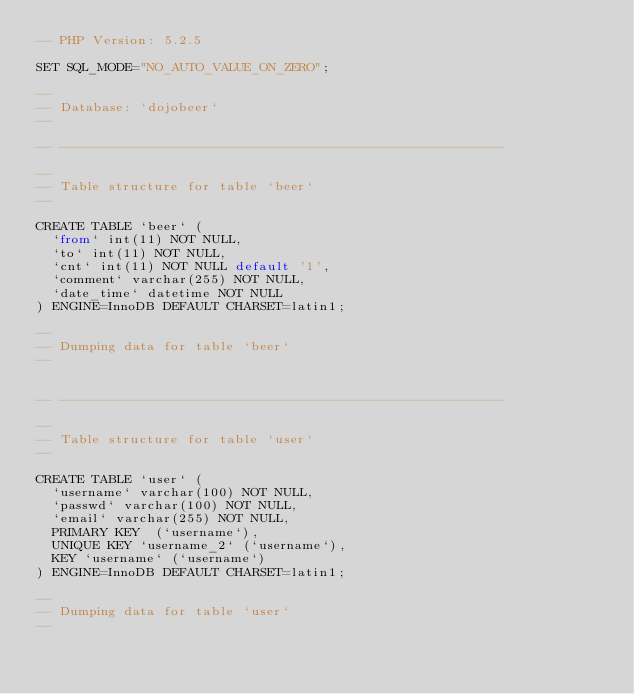Convert code to text. <code><loc_0><loc_0><loc_500><loc_500><_SQL_>-- PHP Version: 5.2.5

SET SQL_MODE="NO_AUTO_VALUE_ON_ZERO";

-- 
-- Database: `dojobeer`
-- 

-- --------------------------------------------------------

-- 
-- Table structure for table `beer`
-- 

CREATE TABLE `beer` (
  `from` int(11) NOT NULL,
  `to` int(11) NOT NULL,
  `cnt` int(11) NOT NULL default '1',
  `comment` varchar(255) NOT NULL,
  `date_time` datetime NOT NULL
) ENGINE=InnoDB DEFAULT CHARSET=latin1;

-- 
-- Dumping data for table `beer`
-- 


-- --------------------------------------------------------

-- 
-- Table structure for table `user`
-- 

CREATE TABLE `user` (
  `username` varchar(100) NOT NULL,
  `passwd` varchar(100) NOT NULL,
  `email` varchar(255) NOT NULL,
  PRIMARY KEY  (`username`),
  UNIQUE KEY `username_2` (`username`),
  KEY `username` (`username`)
) ENGINE=InnoDB DEFAULT CHARSET=latin1;

-- 
-- Dumping data for table `user`
-- 

</code> 